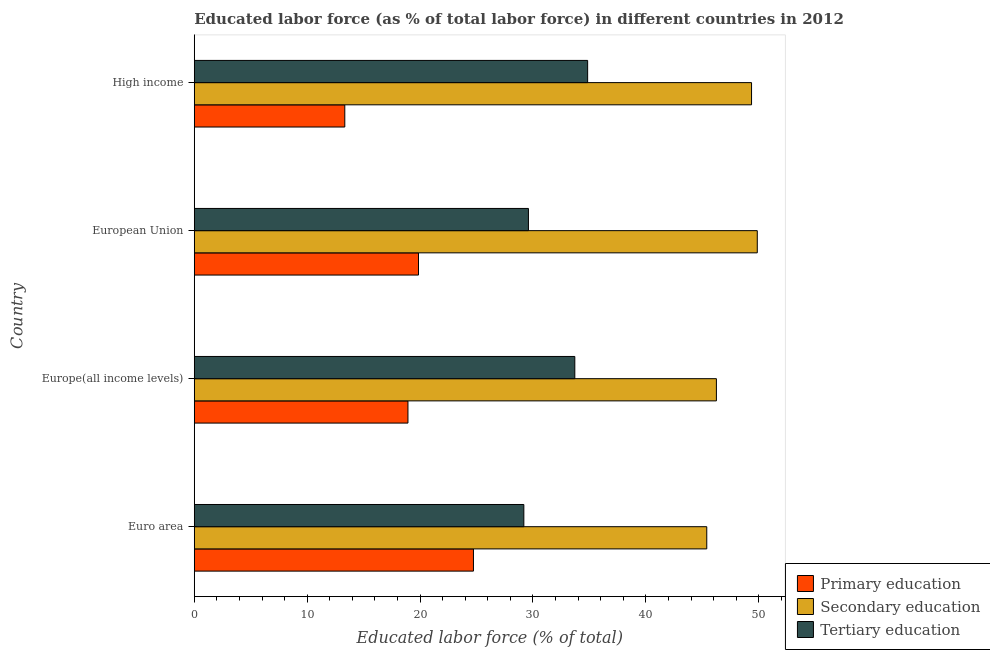How many different coloured bars are there?
Offer a terse response. 3. Are the number of bars per tick equal to the number of legend labels?
Your response must be concise. Yes. How many bars are there on the 3rd tick from the bottom?
Ensure brevity in your answer.  3. What is the percentage of labor force who received tertiary education in Euro area?
Your answer should be very brief. 29.19. Across all countries, what is the maximum percentage of labor force who received primary education?
Your answer should be compact. 24.73. Across all countries, what is the minimum percentage of labor force who received secondary education?
Provide a succinct answer. 45.39. In which country was the percentage of labor force who received secondary education maximum?
Make the answer very short. European Union. What is the total percentage of labor force who received tertiary education in the graph?
Provide a short and direct response. 127.34. What is the difference between the percentage of labor force who received tertiary education in Euro area and that in High income?
Offer a terse response. -5.65. What is the difference between the percentage of labor force who received tertiary education in High income and the percentage of labor force who received primary education in Euro area?
Ensure brevity in your answer.  10.11. What is the average percentage of labor force who received tertiary education per country?
Offer a terse response. 31.83. What is the difference between the percentage of labor force who received secondary education and percentage of labor force who received tertiary education in European Union?
Keep it short and to the point. 20.27. Is the percentage of labor force who received secondary education in Euro area less than that in Europe(all income levels)?
Make the answer very short. Yes. What is the difference between the highest and the second highest percentage of labor force who received tertiary education?
Make the answer very short. 1.14. What is the difference between the highest and the lowest percentage of labor force who received secondary education?
Offer a terse response. 4.47. In how many countries, is the percentage of labor force who received primary education greater than the average percentage of labor force who received primary education taken over all countries?
Offer a very short reply. 2. What does the 2nd bar from the top in Europe(all income levels) represents?
Your response must be concise. Secondary education. What does the 2nd bar from the bottom in High income represents?
Your answer should be very brief. Secondary education. Are all the bars in the graph horizontal?
Offer a terse response. Yes. How many countries are there in the graph?
Provide a succinct answer. 4. Are the values on the major ticks of X-axis written in scientific E-notation?
Your response must be concise. No. How many legend labels are there?
Provide a succinct answer. 3. What is the title of the graph?
Give a very brief answer. Educated labor force (as % of total labor force) in different countries in 2012. Does "Nuclear sources" appear as one of the legend labels in the graph?
Your response must be concise. No. What is the label or title of the X-axis?
Offer a very short reply. Educated labor force (% of total). What is the Educated labor force (% of total) of Primary education in Euro area?
Give a very brief answer. 24.73. What is the Educated labor force (% of total) of Secondary education in Euro area?
Keep it short and to the point. 45.39. What is the Educated labor force (% of total) in Tertiary education in Euro area?
Provide a succinct answer. 29.19. What is the Educated labor force (% of total) of Primary education in Europe(all income levels)?
Your answer should be very brief. 18.93. What is the Educated labor force (% of total) of Secondary education in Europe(all income levels)?
Make the answer very short. 46.25. What is the Educated labor force (% of total) of Tertiary education in Europe(all income levels)?
Offer a terse response. 33.71. What is the Educated labor force (% of total) in Primary education in European Union?
Keep it short and to the point. 19.86. What is the Educated labor force (% of total) of Secondary education in European Union?
Give a very brief answer. 49.87. What is the Educated labor force (% of total) of Tertiary education in European Union?
Your response must be concise. 29.6. What is the Educated labor force (% of total) in Primary education in High income?
Provide a succinct answer. 13.33. What is the Educated labor force (% of total) of Secondary education in High income?
Ensure brevity in your answer.  49.36. What is the Educated labor force (% of total) in Tertiary education in High income?
Make the answer very short. 34.84. Across all countries, what is the maximum Educated labor force (% of total) in Primary education?
Your answer should be very brief. 24.73. Across all countries, what is the maximum Educated labor force (% of total) in Secondary education?
Your answer should be compact. 49.87. Across all countries, what is the maximum Educated labor force (% of total) of Tertiary education?
Keep it short and to the point. 34.84. Across all countries, what is the minimum Educated labor force (% of total) in Primary education?
Your answer should be very brief. 13.33. Across all countries, what is the minimum Educated labor force (% of total) of Secondary education?
Your response must be concise. 45.39. Across all countries, what is the minimum Educated labor force (% of total) of Tertiary education?
Ensure brevity in your answer.  29.19. What is the total Educated labor force (% of total) of Primary education in the graph?
Make the answer very short. 76.85. What is the total Educated labor force (% of total) in Secondary education in the graph?
Make the answer very short. 190.87. What is the total Educated labor force (% of total) in Tertiary education in the graph?
Give a very brief answer. 127.34. What is the difference between the Educated labor force (% of total) in Primary education in Euro area and that in Europe(all income levels)?
Provide a succinct answer. 5.8. What is the difference between the Educated labor force (% of total) of Secondary education in Euro area and that in Europe(all income levels)?
Your answer should be very brief. -0.85. What is the difference between the Educated labor force (% of total) in Tertiary education in Euro area and that in Europe(all income levels)?
Ensure brevity in your answer.  -4.51. What is the difference between the Educated labor force (% of total) in Primary education in Euro area and that in European Union?
Your answer should be compact. 4.87. What is the difference between the Educated labor force (% of total) in Secondary education in Euro area and that in European Union?
Your answer should be compact. -4.47. What is the difference between the Educated labor force (% of total) in Tertiary education in Euro area and that in European Union?
Keep it short and to the point. -0.41. What is the difference between the Educated labor force (% of total) in Primary education in Euro area and that in High income?
Your answer should be very brief. 11.4. What is the difference between the Educated labor force (% of total) of Secondary education in Euro area and that in High income?
Your answer should be very brief. -3.97. What is the difference between the Educated labor force (% of total) in Tertiary education in Euro area and that in High income?
Offer a very short reply. -5.65. What is the difference between the Educated labor force (% of total) in Primary education in Europe(all income levels) and that in European Union?
Your answer should be compact. -0.93. What is the difference between the Educated labor force (% of total) of Secondary education in Europe(all income levels) and that in European Union?
Offer a very short reply. -3.62. What is the difference between the Educated labor force (% of total) of Tertiary education in Europe(all income levels) and that in European Union?
Ensure brevity in your answer.  4.11. What is the difference between the Educated labor force (% of total) in Primary education in Europe(all income levels) and that in High income?
Provide a succinct answer. 5.59. What is the difference between the Educated labor force (% of total) in Secondary education in Europe(all income levels) and that in High income?
Your answer should be compact. -3.11. What is the difference between the Educated labor force (% of total) in Tertiary education in Europe(all income levels) and that in High income?
Your answer should be very brief. -1.14. What is the difference between the Educated labor force (% of total) in Primary education in European Union and that in High income?
Your answer should be compact. 6.53. What is the difference between the Educated labor force (% of total) in Secondary education in European Union and that in High income?
Your answer should be very brief. 0.51. What is the difference between the Educated labor force (% of total) in Tertiary education in European Union and that in High income?
Offer a terse response. -5.24. What is the difference between the Educated labor force (% of total) of Primary education in Euro area and the Educated labor force (% of total) of Secondary education in Europe(all income levels)?
Provide a succinct answer. -21.52. What is the difference between the Educated labor force (% of total) of Primary education in Euro area and the Educated labor force (% of total) of Tertiary education in Europe(all income levels)?
Your answer should be compact. -8.98. What is the difference between the Educated labor force (% of total) of Secondary education in Euro area and the Educated labor force (% of total) of Tertiary education in Europe(all income levels)?
Make the answer very short. 11.69. What is the difference between the Educated labor force (% of total) of Primary education in Euro area and the Educated labor force (% of total) of Secondary education in European Union?
Offer a very short reply. -25.14. What is the difference between the Educated labor force (% of total) of Primary education in Euro area and the Educated labor force (% of total) of Tertiary education in European Union?
Give a very brief answer. -4.87. What is the difference between the Educated labor force (% of total) in Secondary education in Euro area and the Educated labor force (% of total) in Tertiary education in European Union?
Your answer should be very brief. 15.8. What is the difference between the Educated labor force (% of total) of Primary education in Euro area and the Educated labor force (% of total) of Secondary education in High income?
Your answer should be very brief. -24.63. What is the difference between the Educated labor force (% of total) in Primary education in Euro area and the Educated labor force (% of total) in Tertiary education in High income?
Offer a terse response. -10.11. What is the difference between the Educated labor force (% of total) in Secondary education in Euro area and the Educated labor force (% of total) in Tertiary education in High income?
Keep it short and to the point. 10.55. What is the difference between the Educated labor force (% of total) of Primary education in Europe(all income levels) and the Educated labor force (% of total) of Secondary education in European Union?
Offer a very short reply. -30.94. What is the difference between the Educated labor force (% of total) of Primary education in Europe(all income levels) and the Educated labor force (% of total) of Tertiary education in European Union?
Keep it short and to the point. -10.67. What is the difference between the Educated labor force (% of total) in Secondary education in Europe(all income levels) and the Educated labor force (% of total) in Tertiary education in European Union?
Your answer should be compact. 16.65. What is the difference between the Educated labor force (% of total) in Primary education in Europe(all income levels) and the Educated labor force (% of total) in Secondary education in High income?
Provide a short and direct response. -30.43. What is the difference between the Educated labor force (% of total) of Primary education in Europe(all income levels) and the Educated labor force (% of total) of Tertiary education in High income?
Provide a succinct answer. -15.91. What is the difference between the Educated labor force (% of total) in Secondary education in Europe(all income levels) and the Educated labor force (% of total) in Tertiary education in High income?
Provide a short and direct response. 11.4. What is the difference between the Educated labor force (% of total) of Primary education in European Union and the Educated labor force (% of total) of Secondary education in High income?
Your answer should be compact. -29.5. What is the difference between the Educated labor force (% of total) of Primary education in European Union and the Educated labor force (% of total) of Tertiary education in High income?
Provide a short and direct response. -14.98. What is the difference between the Educated labor force (% of total) in Secondary education in European Union and the Educated labor force (% of total) in Tertiary education in High income?
Offer a terse response. 15.02. What is the average Educated labor force (% of total) of Primary education per country?
Keep it short and to the point. 19.21. What is the average Educated labor force (% of total) in Secondary education per country?
Make the answer very short. 47.72. What is the average Educated labor force (% of total) of Tertiary education per country?
Give a very brief answer. 31.83. What is the difference between the Educated labor force (% of total) in Primary education and Educated labor force (% of total) in Secondary education in Euro area?
Give a very brief answer. -20.67. What is the difference between the Educated labor force (% of total) in Primary education and Educated labor force (% of total) in Tertiary education in Euro area?
Make the answer very short. -4.46. What is the difference between the Educated labor force (% of total) of Secondary education and Educated labor force (% of total) of Tertiary education in Euro area?
Your answer should be very brief. 16.2. What is the difference between the Educated labor force (% of total) in Primary education and Educated labor force (% of total) in Secondary education in Europe(all income levels)?
Your answer should be very brief. -27.32. What is the difference between the Educated labor force (% of total) in Primary education and Educated labor force (% of total) in Tertiary education in Europe(all income levels)?
Ensure brevity in your answer.  -14.78. What is the difference between the Educated labor force (% of total) in Secondary education and Educated labor force (% of total) in Tertiary education in Europe(all income levels)?
Offer a very short reply. 12.54. What is the difference between the Educated labor force (% of total) in Primary education and Educated labor force (% of total) in Secondary education in European Union?
Provide a short and direct response. -30.01. What is the difference between the Educated labor force (% of total) of Primary education and Educated labor force (% of total) of Tertiary education in European Union?
Your answer should be very brief. -9.74. What is the difference between the Educated labor force (% of total) of Secondary education and Educated labor force (% of total) of Tertiary education in European Union?
Provide a succinct answer. 20.27. What is the difference between the Educated labor force (% of total) in Primary education and Educated labor force (% of total) in Secondary education in High income?
Offer a terse response. -36.03. What is the difference between the Educated labor force (% of total) in Primary education and Educated labor force (% of total) in Tertiary education in High income?
Give a very brief answer. -21.51. What is the difference between the Educated labor force (% of total) of Secondary education and Educated labor force (% of total) of Tertiary education in High income?
Provide a short and direct response. 14.52. What is the ratio of the Educated labor force (% of total) of Primary education in Euro area to that in Europe(all income levels)?
Provide a short and direct response. 1.31. What is the ratio of the Educated labor force (% of total) of Secondary education in Euro area to that in Europe(all income levels)?
Provide a short and direct response. 0.98. What is the ratio of the Educated labor force (% of total) of Tertiary education in Euro area to that in Europe(all income levels)?
Ensure brevity in your answer.  0.87. What is the ratio of the Educated labor force (% of total) in Primary education in Euro area to that in European Union?
Ensure brevity in your answer.  1.25. What is the ratio of the Educated labor force (% of total) in Secondary education in Euro area to that in European Union?
Your answer should be very brief. 0.91. What is the ratio of the Educated labor force (% of total) of Tertiary education in Euro area to that in European Union?
Your response must be concise. 0.99. What is the ratio of the Educated labor force (% of total) of Primary education in Euro area to that in High income?
Your answer should be compact. 1.85. What is the ratio of the Educated labor force (% of total) of Secondary education in Euro area to that in High income?
Offer a terse response. 0.92. What is the ratio of the Educated labor force (% of total) in Tertiary education in Euro area to that in High income?
Keep it short and to the point. 0.84. What is the ratio of the Educated labor force (% of total) of Primary education in Europe(all income levels) to that in European Union?
Offer a very short reply. 0.95. What is the ratio of the Educated labor force (% of total) in Secondary education in Europe(all income levels) to that in European Union?
Your answer should be compact. 0.93. What is the ratio of the Educated labor force (% of total) of Tertiary education in Europe(all income levels) to that in European Union?
Your response must be concise. 1.14. What is the ratio of the Educated labor force (% of total) in Primary education in Europe(all income levels) to that in High income?
Ensure brevity in your answer.  1.42. What is the ratio of the Educated labor force (% of total) in Secondary education in Europe(all income levels) to that in High income?
Make the answer very short. 0.94. What is the ratio of the Educated labor force (% of total) of Tertiary education in Europe(all income levels) to that in High income?
Offer a very short reply. 0.97. What is the ratio of the Educated labor force (% of total) in Primary education in European Union to that in High income?
Keep it short and to the point. 1.49. What is the ratio of the Educated labor force (% of total) in Secondary education in European Union to that in High income?
Give a very brief answer. 1.01. What is the ratio of the Educated labor force (% of total) in Tertiary education in European Union to that in High income?
Provide a short and direct response. 0.85. What is the difference between the highest and the second highest Educated labor force (% of total) in Primary education?
Give a very brief answer. 4.87. What is the difference between the highest and the second highest Educated labor force (% of total) of Secondary education?
Your answer should be compact. 0.51. What is the difference between the highest and the second highest Educated labor force (% of total) in Tertiary education?
Offer a very short reply. 1.14. What is the difference between the highest and the lowest Educated labor force (% of total) of Primary education?
Offer a very short reply. 11.4. What is the difference between the highest and the lowest Educated labor force (% of total) of Secondary education?
Your answer should be very brief. 4.47. What is the difference between the highest and the lowest Educated labor force (% of total) of Tertiary education?
Offer a very short reply. 5.65. 